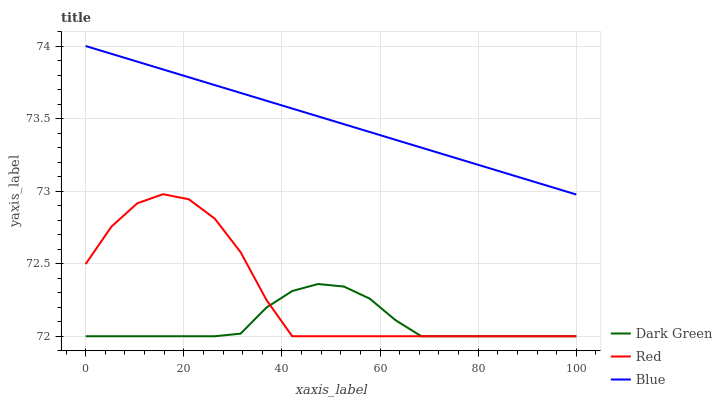Does Red have the minimum area under the curve?
Answer yes or no. No. Does Red have the maximum area under the curve?
Answer yes or no. No. Is Dark Green the smoothest?
Answer yes or no. No. Is Dark Green the roughest?
Answer yes or no. No. Does Red have the highest value?
Answer yes or no. No. Is Red less than Blue?
Answer yes or no. Yes. Is Blue greater than Red?
Answer yes or no. Yes. Does Red intersect Blue?
Answer yes or no. No. 